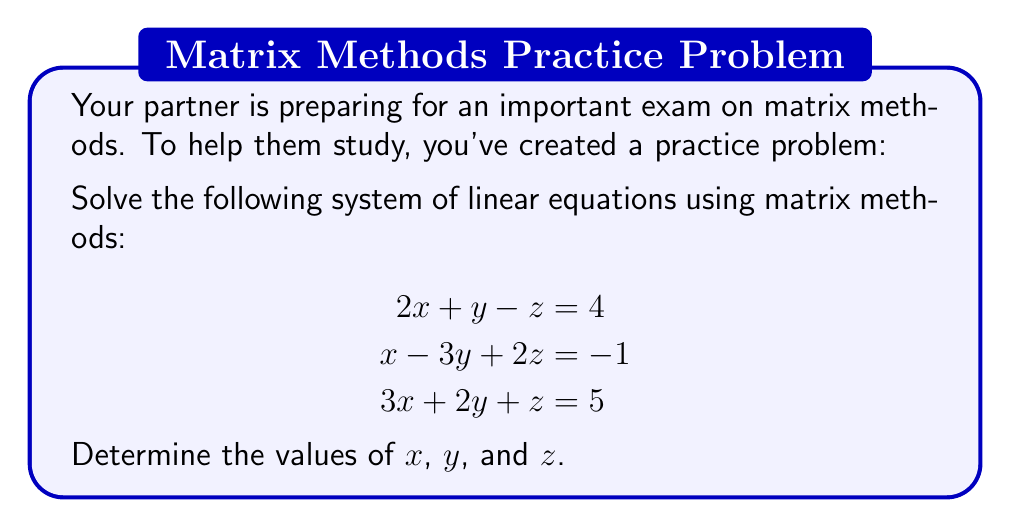Could you help me with this problem? Let's solve this step-by-step using matrix methods:

1) First, we'll write the system in matrix form $AX = B$:

   $$A = \begin{bmatrix}
   2 & 1 & -1 \\
   1 & -3 & 2 \\
   3 & 2 & 1
   \end{bmatrix}, \quad
   X = \begin{bmatrix}
   x \\ y \\ z
   \end{bmatrix}, \quad
   B = \begin{bmatrix}
   4 \\ -1 \\ 5
   \end{bmatrix}$$

2) To solve for $X$, we need to find $A^{-1}$ and then compute $X = A^{-1}B$.

3) Let's find $A^{-1}$ using the adjugate method:
   
   a) Calculate the determinant of $A$:
      $\det(A) = 2(-3-2) + 1(2-3) + (-1)(1+6) = -10 - 1 - 7 = -18$

   b) Find the adjugate matrix:
      $$\text{adj}(A) = \begin{bmatrix}
      -5 & -4 & -3 \\
      -7 & 3 & -5 \\
      -1 & -2 & -7
      \end{bmatrix}$$

   c) Calculate $A^{-1} = \frac{1}{\det(A)} \text{adj}(A)$:
      $$A^{-1} = -\frac{1}{18} \begin{bmatrix}
      5 & 4 & 3 \\
      7 & -3 & 5 \\
      1 & 2 & 7
      \end{bmatrix}$$

4) Now we can solve for $X$:
   $$X = A^{-1}B = -\frac{1}{18} \begin{bmatrix}
   5 & 4 & 3 \\
   7 & -3 & 5 \\
   1 & 2 & 7
   \end{bmatrix} \begin{bmatrix}
   4 \\ -1 \\ 5
   \end{bmatrix}$$

5) Multiplying these matrices:
   $$X = -\frac{1}{18} \begin{bmatrix}
   5(4) + 4(-1) + 3(5) \\
   7(4) + (-3)(-1) + 5(5) \\
   1(4) + 2(-1) + 7(5)
   \end{bmatrix} = -\frac{1}{18} \begin{bmatrix}
   36 \\
   54 \\
   38
   \end{bmatrix}$$

6) Simplifying:
   $$X = \begin{bmatrix}
   -2 \\
   -3 \\
   -\frac{19}{9}
   \end{bmatrix}$$

Therefore, $x = -2$, $y = -3$, and $z = -\frac{19}{9}$.
Answer: $x = -2$, $y = -3$, $z = -\frac{19}{9}$ 